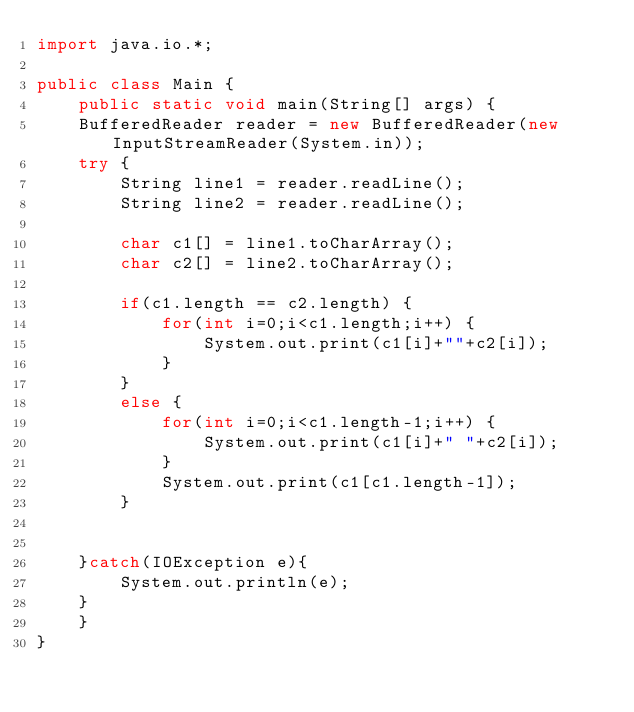<code> <loc_0><loc_0><loc_500><loc_500><_Java_>import java.io.*;

public class Main {
	public static void main(String[] args) {
	BufferedReader reader = new BufferedReader(new InputStreamReader(System.in));
	try {
		String line1 = reader.readLine();
		String line2 = reader.readLine();
		
		char c1[] = line1.toCharArray();
		char c2[] = line2.toCharArray();
		
		if(c1.length == c2.length) {
			for(int i=0;i<c1.length;i++) {
				System.out.print(c1[i]+""+c2[i]);
			}
		}
		else {
			for(int i=0;i<c1.length-1;i++) {
				System.out.print(c1[i]+" "+c2[i]);
			}
			System.out.print(c1[c1.length-1]);
		}
		
		
	}catch(IOException e){
		System.out.println(e);
	}
	}
}</code> 